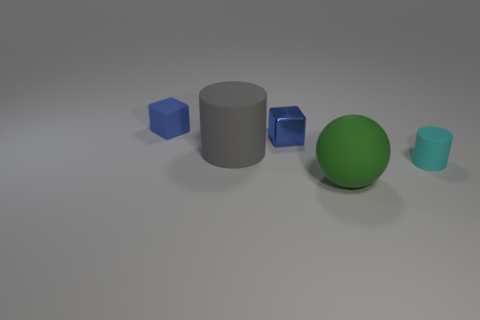Add 2 big purple metal objects. How many objects exist? 7 Subtract all cylinders. How many objects are left? 3 Add 2 matte things. How many matte things are left? 6 Add 3 tiny cubes. How many tiny cubes exist? 5 Subtract 1 gray cylinders. How many objects are left? 4 Subtract all large gray rubber things. Subtract all large spheres. How many objects are left? 3 